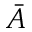Convert formula to latex. <formula><loc_0><loc_0><loc_500><loc_500>\bar { A }</formula> 